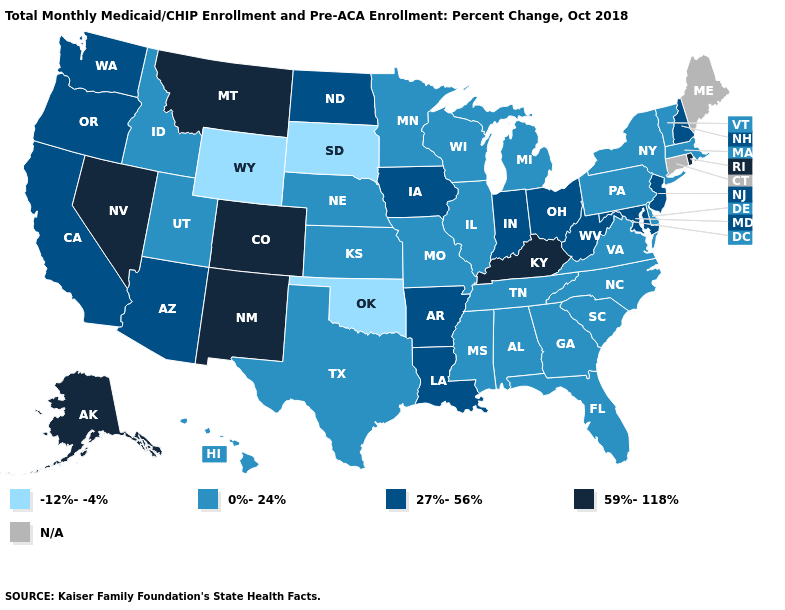Which states have the lowest value in the USA?
Short answer required. Oklahoma, South Dakota, Wyoming. What is the value of Missouri?
Concise answer only. 0%-24%. Name the states that have a value in the range N/A?
Give a very brief answer. Connecticut, Maine. Among the states that border North Dakota , does Minnesota have the lowest value?
Quick response, please. No. Is the legend a continuous bar?
Concise answer only. No. Does Georgia have the highest value in the USA?
Quick response, please. No. Which states have the lowest value in the USA?
Answer briefly. Oklahoma, South Dakota, Wyoming. What is the value of Alabama?
Be succinct. 0%-24%. What is the value of Iowa?
Keep it brief. 27%-56%. What is the highest value in the USA?
Give a very brief answer. 59%-118%. Name the states that have a value in the range 27%-56%?
Answer briefly. Arizona, Arkansas, California, Indiana, Iowa, Louisiana, Maryland, New Hampshire, New Jersey, North Dakota, Ohio, Oregon, Washington, West Virginia. What is the lowest value in the Northeast?
Answer briefly. 0%-24%. What is the value of Pennsylvania?
Give a very brief answer. 0%-24%. What is the value of Indiana?
Be succinct. 27%-56%. 